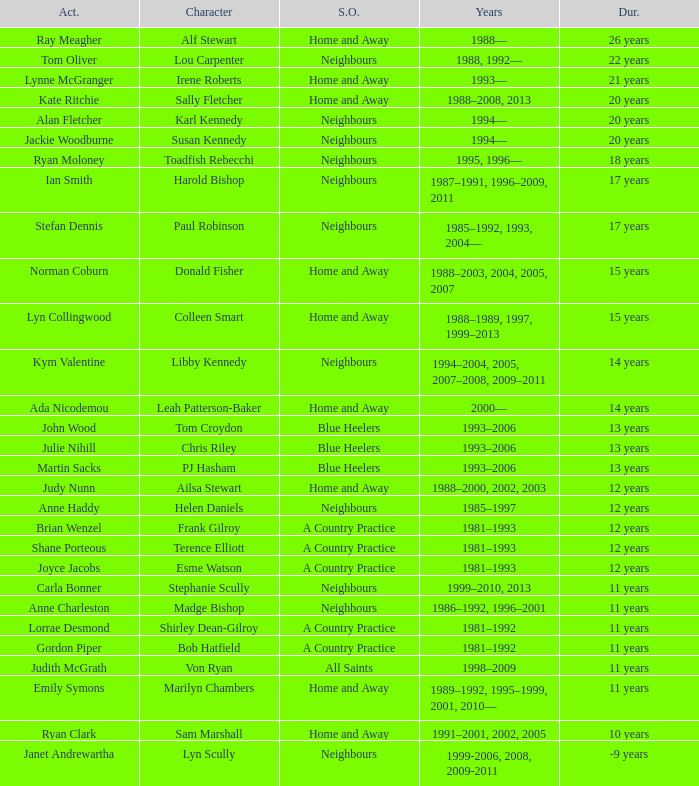Which actor played on Home and Away for 20 years? Kate Ritchie. 